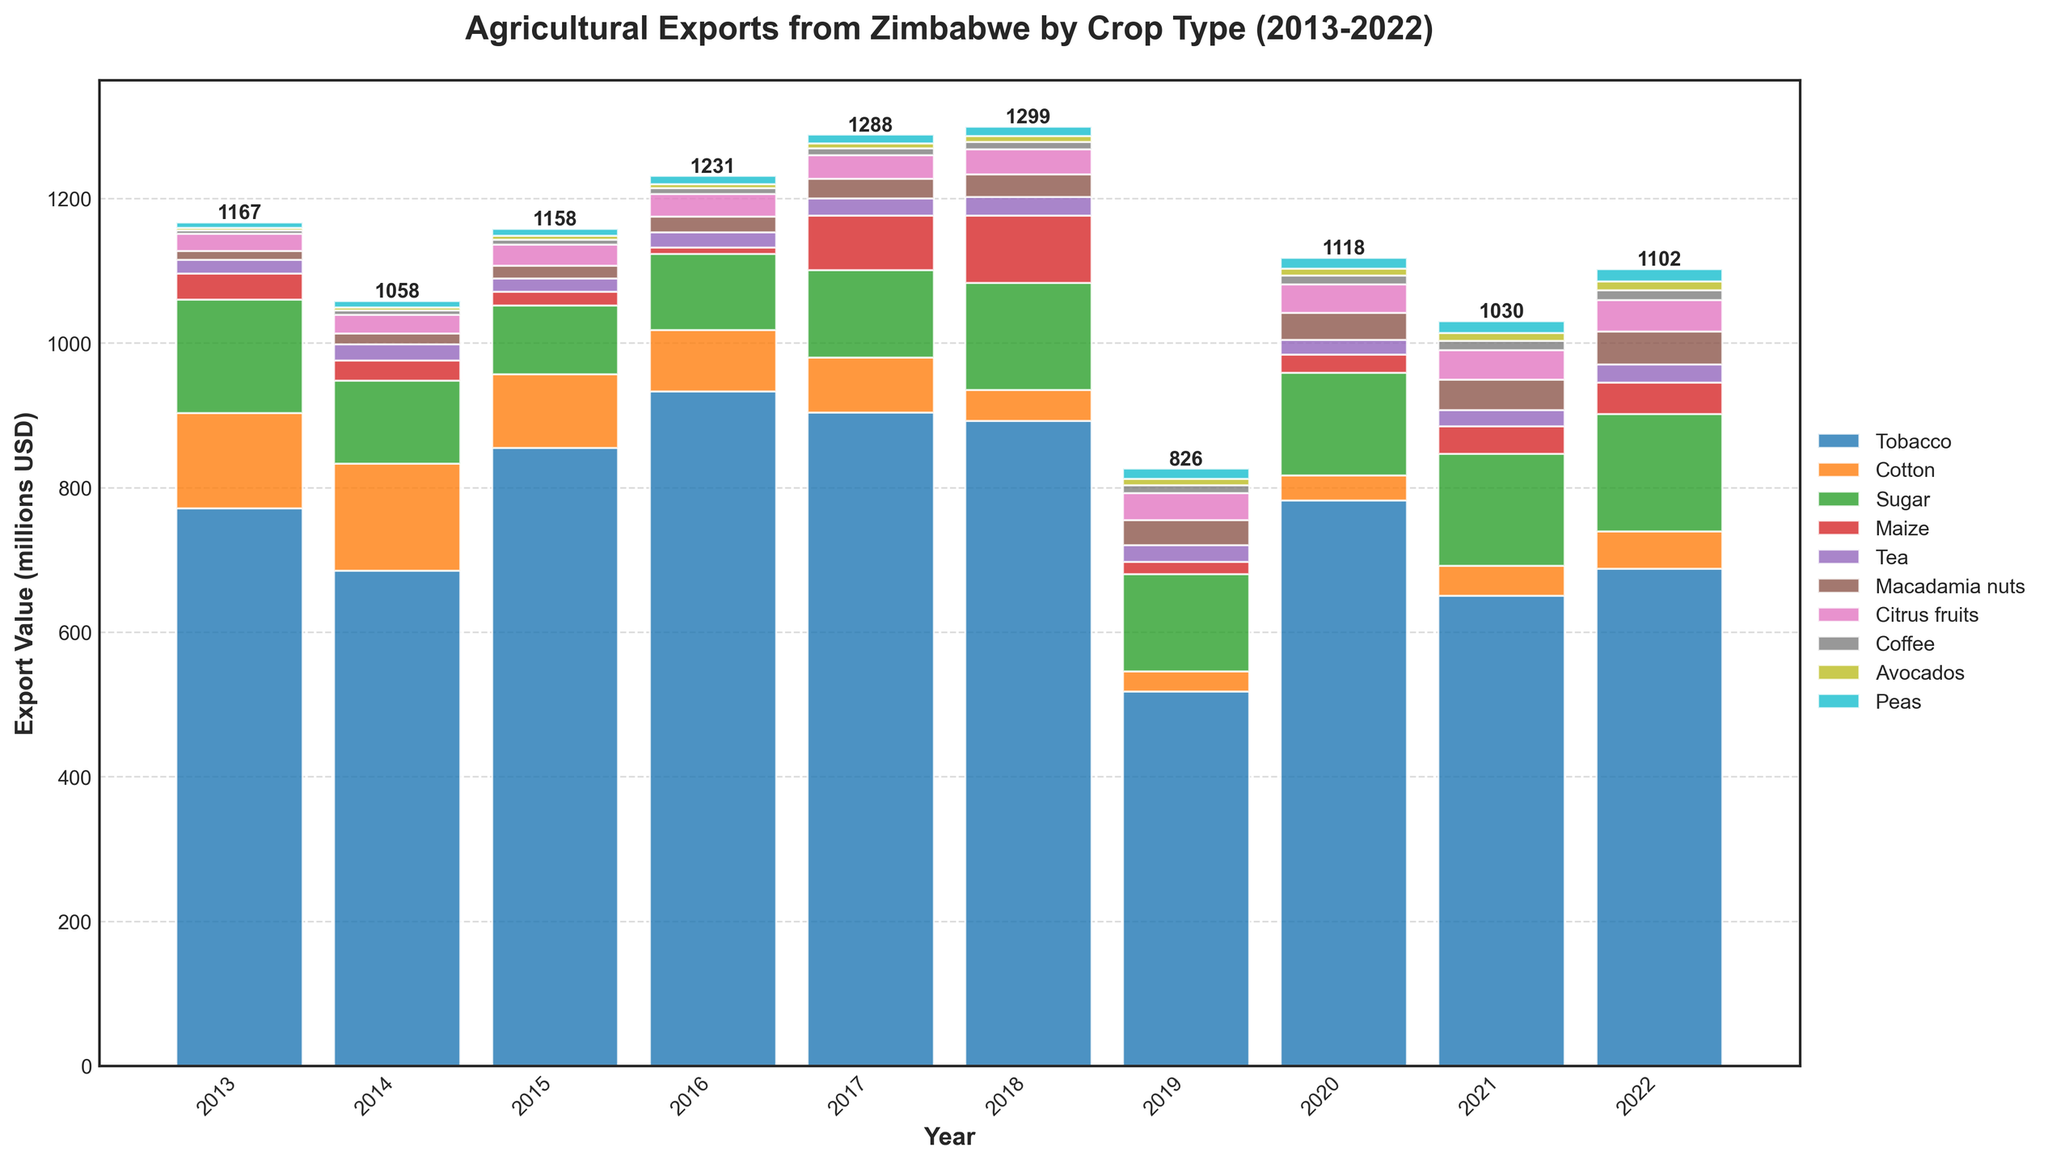What crop had the highest export value in 2017? The tallest bar in the year 2017 represents the highest export value. The bar corresponding to Tobacco is significantly taller than the others.
Answer: Tobacco Which crop showed the most consistent growth in export value over the years? To determine consistent growth, examine the bars for each crop across all years to identify stable, gradual increases. Macadamia nuts show a steady rise each year.
Answer: Macadamia nuts How much did maize export values increase from 2016 to 2017? Locate the bar heights for maize in 2016 and 2017, then subtract the 2016 value from the 2017 value (75 - 9).
Answer: 66 million USD Which year had the lowest total agricultural export value? Sum the heights of the bars for each year and compare. 2015 appears to have the shortest combined bar height.
Answer: 2015 In which year did tobacco exports drop the most compared to the previous year, and by how much? Look at the year-on-year differences in the height of the tobacco bars to find the biggest decrease. The largest drop is from 2019 to 2020: 518 - 782.
Answer: 2020, 264 million USD What was the combined export value of sugar and citrus fruits in 2022? Add up the values for sugar (163) and citrus fruits (43) in 2022.
Answer: 206 million USD Which crop had the smallest export value in 2013? Identify the shortest bar in 2013, which belongs to Avocados.
Answer: Avocados How did the export value of tea in 2018 compare to that of tea in 2013? Compare the bar heights for tea in 2018 (26) and 2013 (19).
Answer: The export value increased by 7 million USD Which crops showed a decline in export value in 2019 compared to 2018? Compare the bar heights for each crop between 2018 and 2019. Both Tobacco and Cotton show a decline.
Answer: Tobacco, Cotton What was the average export value of coffee from 2013 to 2022? Sum the values for coffee from 2013 to 2022 and divide by the number of years (5 + 6 + 7 + 8 + 9 + 10 + 11 + 12 + 13 + 14 = 95; then 95 / 10).
Answer: 9.5 million USD 